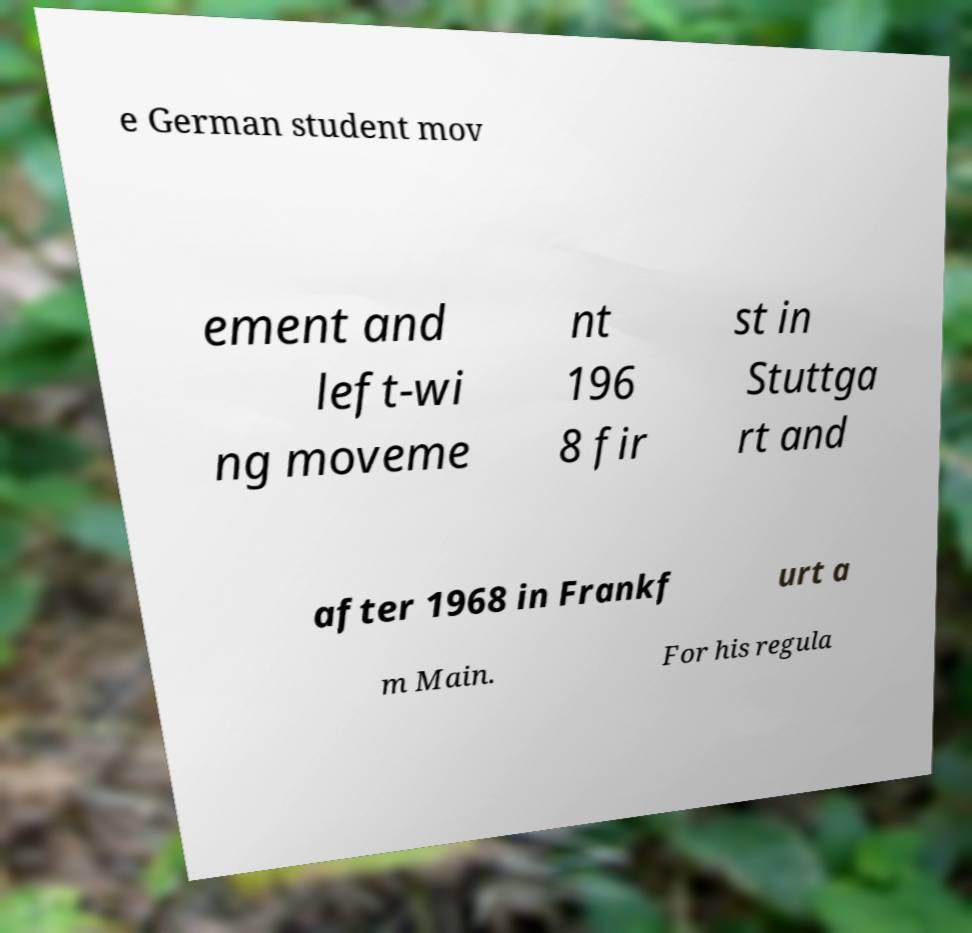I need the written content from this picture converted into text. Can you do that? e German student mov ement and left-wi ng moveme nt 196 8 fir st in Stuttga rt and after 1968 in Frankf urt a m Main. For his regula 